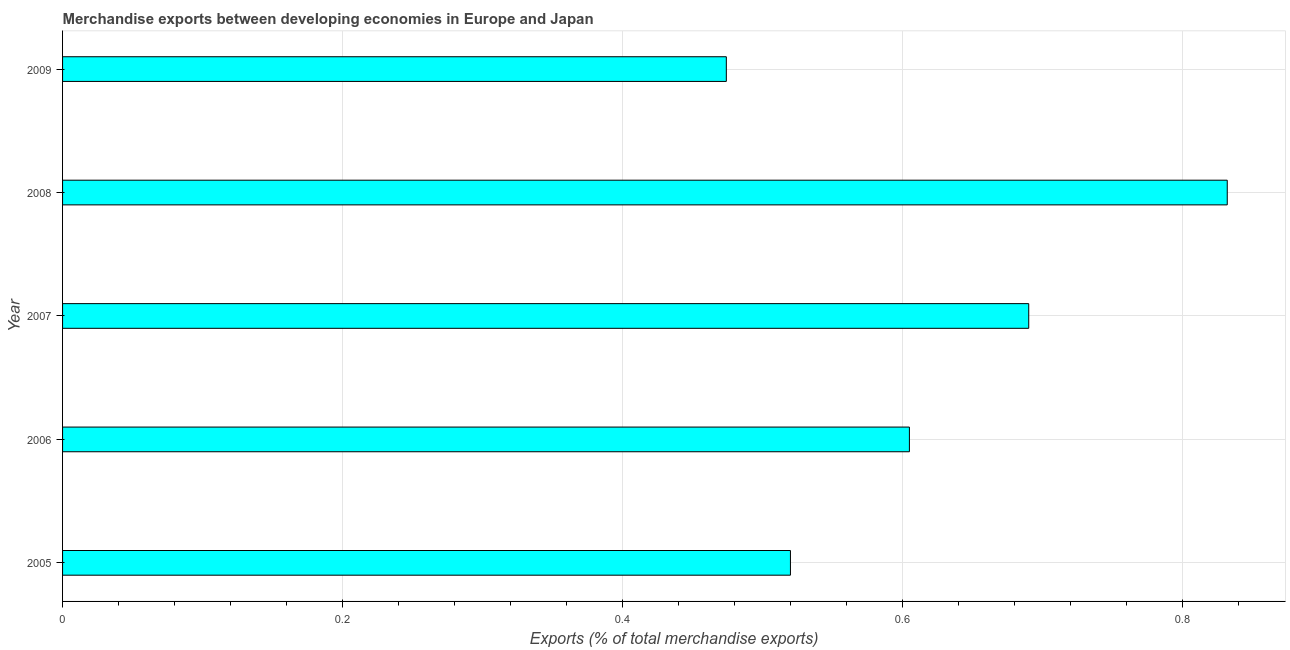What is the title of the graph?
Offer a terse response. Merchandise exports between developing economies in Europe and Japan. What is the label or title of the X-axis?
Your response must be concise. Exports (% of total merchandise exports). What is the merchandise exports in 2008?
Keep it short and to the point. 0.83. Across all years, what is the maximum merchandise exports?
Keep it short and to the point. 0.83. Across all years, what is the minimum merchandise exports?
Your answer should be very brief. 0.47. What is the sum of the merchandise exports?
Keep it short and to the point. 3.12. What is the difference between the merchandise exports in 2005 and 2008?
Provide a succinct answer. -0.31. What is the average merchandise exports per year?
Your answer should be very brief. 0.62. What is the median merchandise exports?
Provide a short and direct response. 0.61. In how many years, is the merchandise exports greater than 0.8 %?
Give a very brief answer. 1. What is the ratio of the merchandise exports in 2006 to that in 2007?
Provide a short and direct response. 0.88. Is the difference between the merchandise exports in 2007 and 2008 greater than the difference between any two years?
Offer a terse response. No. What is the difference between the highest and the second highest merchandise exports?
Offer a terse response. 0.14. Is the sum of the merchandise exports in 2006 and 2007 greater than the maximum merchandise exports across all years?
Keep it short and to the point. Yes. What is the difference between the highest and the lowest merchandise exports?
Offer a very short reply. 0.36. In how many years, is the merchandise exports greater than the average merchandise exports taken over all years?
Provide a short and direct response. 2. How many years are there in the graph?
Give a very brief answer. 5. What is the Exports (% of total merchandise exports) in 2005?
Provide a short and direct response. 0.52. What is the Exports (% of total merchandise exports) of 2006?
Keep it short and to the point. 0.61. What is the Exports (% of total merchandise exports) of 2007?
Your response must be concise. 0.69. What is the Exports (% of total merchandise exports) in 2008?
Keep it short and to the point. 0.83. What is the Exports (% of total merchandise exports) of 2009?
Give a very brief answer. 0.47. What is the difference between the Exports (% of total merchandise exports) in 2005 and 2006?
Give a very brief answer. -0.09. What is the difference between the Exports (% of total merchandise exports) in 2005 and 2007?
Offer a terse response. -0.17. What is the difference between the Exports (% of total merchandise exports) in 2005 and 2008?
Make the answer very short. -0.31. What is the difference between the Exports (% of total merchandise exports) in 2005 and 2009?
Your answer should be very brief. 0.05. What is the difference between the Exports (% of total merchandise exports) in 2006 and 2007?
Your answer should be very brief. -0.09. What is the difference between the Exports (% of total merchandise exports) in 2006 and 2008?
Your answer should be very brief. -0.23. What is the difference between the Exports (% of total merchandise exports) in 2006 and 2009?
Make the answer very short. 0.13. What is the difference between the Exports (% of total merchandise exports) in 2007 and 2008?
Offer a terse response. -0.14. What is the difference between the Exports (% of total merchandise exports) in 2007 and 2009?
Your response must be concise. 0.22. What is the difference between the Exports (% of total merchandise exports) in 2008 and 2009?
Your answer should be compact. 0.36. What is the ratio of the Exports (% of total merchandise exports) in 2005 to that in 2006?
Provide a succinct answer. 0.86. What is the ratio of the Exports (% of total merchandise exports) in 2005 to that in 2007?
Offer a very short reply. 0.75. What is the ratio of the Exports (% of total merchandise exports) in 2005 to that in 2008?
Your response must be concise. 0.62. What is the ratio of the Exports (% of total merchandise exports) in 2005 to that in 2009?
Offer a terse response. 1.1. What is the ratio of the Exports (% of total merchandise exports) in 2006 to that in 2007?
Offer a terse response. 0.88. What is the ratio of the Exports (% of total merchandise exports) in 2006 to that in 2008?
Provide a succinct answer. 0.73. What is the ratio of the Exports (% of total merchandise exports) in 2006 to that in 2009?
Your answer should be very brief. 1.28. What is the ratio of the Exports (% of total merchandise exports) in 2007 to that in 2008?
Make the answer very short. 0.83. What is the ratio of the Exports (% of total merchandise exports) in 2007 to that in 2009?
Offer a very short reply. 1.46. What is the ratio of the Exports (% of total merchandise exports) in 2008 to that in 2009?
Ensure brevity in your answer.  1.75. 